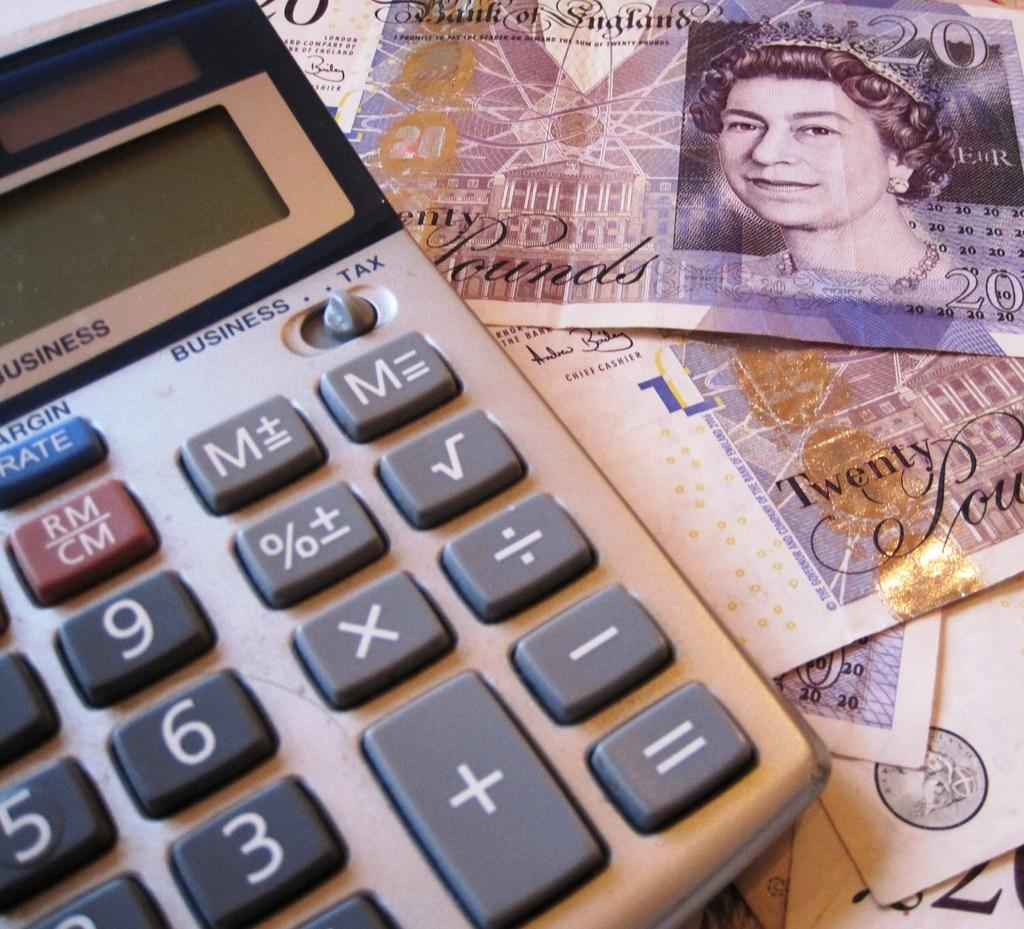<image>
Create a compact narrative representing the image presented. A business calculator beside a British currency that reads Bank of England and twenty pounds. 